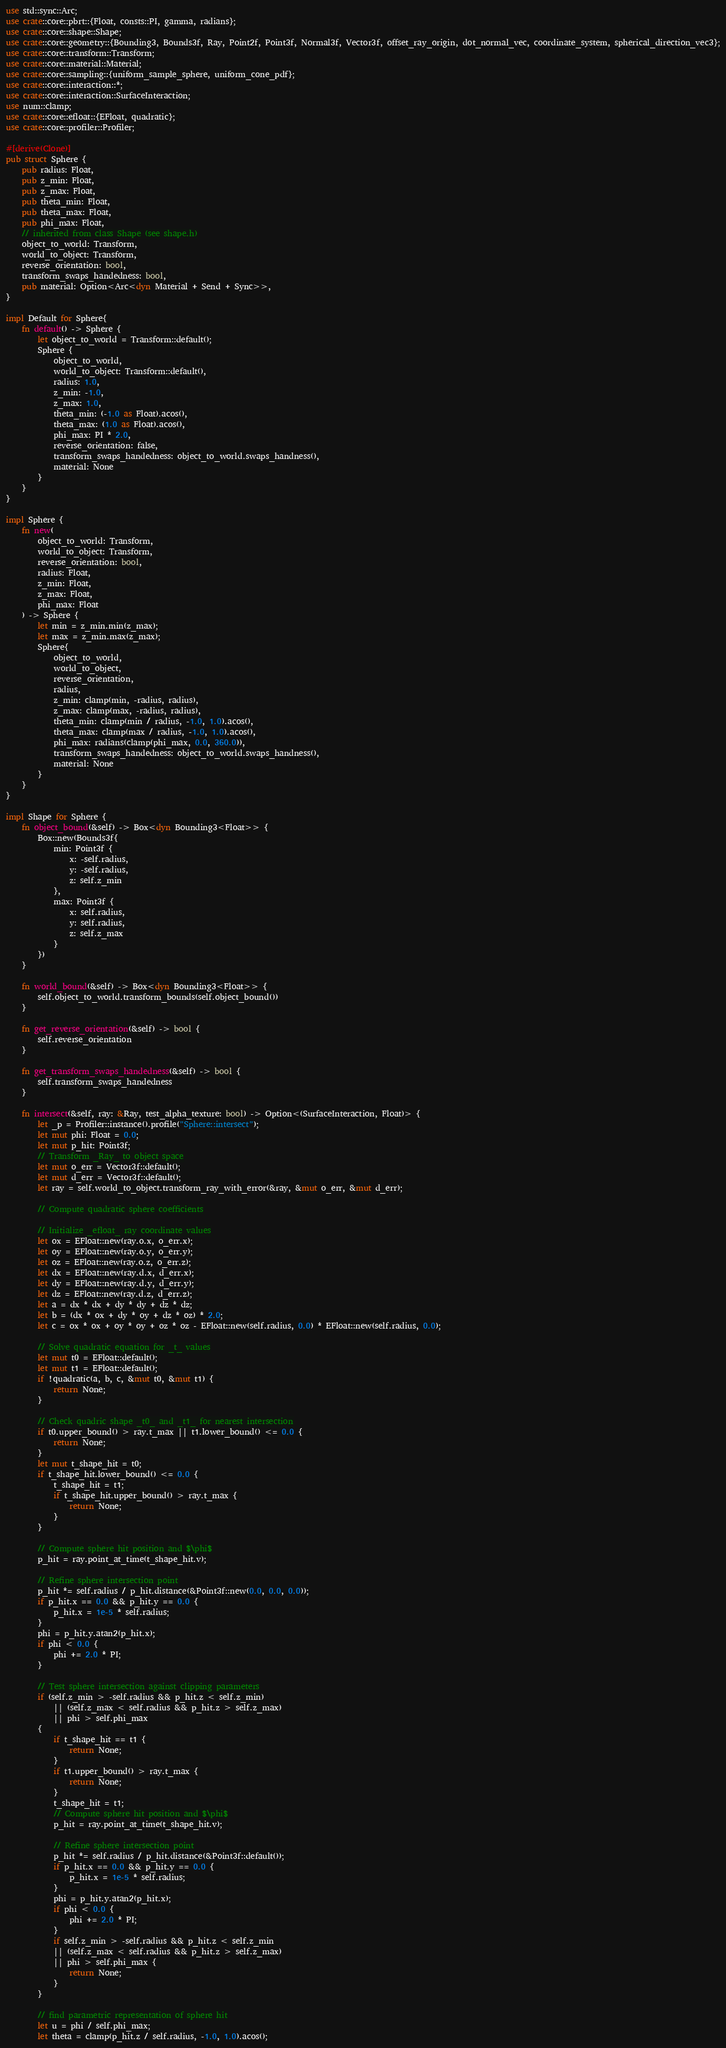<code> <loc_0><loc_0><loc_500><loc_500><_Rust_>use std::sync::Arc;
use crate::core::pbrt::{Float, consts::PI, gamma, radians};
use crate::core::shape::Shape;
use crate::core::geometry::{Bounding3, Bounds3f, Ray, Point2f, Point3f, Normal3f, Vector3f, offset_ray_origin, dot_normal_vec, coordinate_system, spherical_direction_vec3};
use crate::core::transform::Transform;
use crate::core::material::Material;
use crate::core::sampling::{uniform_sample_sphere, uniform_cone_pdf};
use crate::core::interaction::*;
use crate::core::interaction::SurfaceInteraction;
use num::clamp;
use crate::core::efloat::{EFloat, quadratic};
use crate::core::profiler::Profiler;

#[derive(Clone)]
pub struct Sphere {
    pub radius: Float,
    pub z_min: Float,
    pub z_max: Float,
    pub theta_min: Float,
    pub theta_max: Float,
    pub phi_max: Float,
    // inherited from class Shape (see shape.h)
    object_to_world: Transform,
    world_to_object: Transform,
    reverse_orientation: bool,
    transform_swaps_handedness: bool,
    pub material: Option<Arc<dyn Material + Send + Sync>>,
}

impl Default for Sphere{
    fn default() -> Sphere {
        let object_to_world = Transform::default();
        Sphere {
            object_to_world,
            world_to_object: Transform::default(),
            radius: 1.0,
            z_min: -1.0,
            z_max: 1.0,
            theta_min: (-1.0 as Float).acos(),
            theta_max: (1.0 as Float).acos(),
            phi_max: PI * 2.0,
            reverse_orientation: false,
            transform_swaps_handedness: object_to_world.swaps_handness(),
            material: None
        }
    }
}

impl Sphere {
    fn new(
        object_to_world: Transform,
        world_to_object: Transform,
        reverse_orientation: bool,
        radius: Float,
        z_min: Float,
        z_max: Float,
        phi_max: Float
    ) -> Sphere {
        let min = z_min.min(z_max);
        let max = z_min.max(z_max);
        Sphere{
            object_to_world,
            world_to_object,
            reverse_orientation,
            radius,
            z_min: clamp(min, -radius, radius),
            z_max: clamp(max, -radius, radius),
            theta_min: clamp(min / radius, -1.0, 1.0).acos(),
            theta_max: clamp(max / radius, -1.0, 1.0).acos(),
            phi_max: radians(clamp(phi_max, 0.0, 360.0)),
            transform_swaps_handedness: object_to_world.swaps_handness(),
            material: None
        }
    }
}

impl Shape for Sphere {
    fn object_bound(&self) -> Box<dyn Bounding3<Float>> {
        Box::new(Bounds3f{
            min: Point3f {
                x: -self.radius,
                y: -self.radius,
                z: self.z_min
            },
            max: Point3f {
                x: self.radius,
                y: self.radius,
                z: self.z_max
            }
        })
    }

    fn world_bound(&self) -> Box<dyn Bounding3<Float>> {
        self.object_to_world.transform_bounds(self.object_bound())
    }

    fn get_reverse_orientation(&self) -> bool {
        self.reverse_orientation
    }

    fn get_transform_swaps_handedness(&self) -> bool {
        self.transform_swaps_handedness
    }

    fn intersect(&self, ray: &Ray, test_alpha_texture: bool) -> Option<(SurfaceInteraction, Float)> {
        let _p = Profiler::instance().profile("Sphere::intersect");
        let mut phi: Float = 0.0;
        let mut p_hit: Point3f;
        // Transform _Ray_ to object space
        let mut o_err = Vector3f::default();
        let mut d_err = Vector3f::default();
        let ray = self.world_to_object.transform_ray_with_error(&ray, &mut o_err, &mut d_err);

        // Compute quadratic sphere coefficients

        // Initialize _efloat_ ray coordinate values
        let ox = EFloat::new(ray.o.x, o_err.x);
        let oy = EFloat::new(ray.o.y, o_err.y);
        let oz = EFloat::new(ray.o.z, o_err.z);
        let dx = EFloat::new(ray.d.x, d_err.x);
        let dy = EFloat::new(ray.d.y, d_err.y);
        let dz = EFloat::new(ray.d.z, d_err.z);
        let a = dx * dx + dy * dy + dz * dz;
        let b = (dx * ox + dy * oy + dz * oz) * 2.0;
        let c = ox * ox + oy * oy + oz * oz - EFloat::new(self.radius, 0.0) * EFloat::new(self.radius, 0.0);

        // Solve quadratic equation for _t_ values
        let mut t0 = EFloat::default();
        let mut t1 = EFloat::default();
        if !quadratic(a, b, c, &mut t0, &mut t1) {
            return None;
        }

        // Check quadric shape _t0_ and _t1_ for nearest intersection
        if t0.upper_bound() > ray.t_max || t1.lower_bound() <= 0.0 {
            return None;
        }
        let mut t_shape_hit = t0;
        if t_shape_hit.lower_bound() <= 0.0 {
            t_shape_hit = t1;
            if t_shape_hit.upper_bound() > ray.t_max {
                return None;
            }
        }

        // Compute sphere hit position and $\phi$
        p_hit = ray.point_at_time(t_shape_hit.v);

        // Refine sphere intersection point
        p_hit *= self.radius / p_hit.distance(&Point3f::new(0.0, 0.0, 0.0));
        if p_hit.x == 0.0 && p_hit.y == 0.0 {
            p_hit.x = 1e-5 * self.radius;
        }
        phi = p_hit.y.atan2(p_hit.x);
        if phi < 0.0 {
            phi += 2.0 * PI;
        }

        // Test sphere intersection against clipping parameters
        if (self.z_min > -self.radius && p_hit.z < self.z_min)
            || (self.z_max < self.radius && p_hit.z > self.z_max)
            || phi > self.phi_max
        {
            if t_shape_hit == t1 {
                return None;
            }
            if t1.upper_bound() > ray.t_max {
                return None;
            }
            t_shape_hit = t1;
            // Compute sphere hit position and $\phi$
            p_hit = ray.point_at_time(t_shape_hit.v);

            // Refine sphere intersection point
            p_hit *= self.radius / p_hit.distance(&Point3f::default());
            if p_hit.x == 0.0 && p_hit.y == 0.0 {
                p_hit.x = 1e-5 * self.radius;
            }
            phi = p_hit.y.atan2(p_hit.x);
            if phi < 0.0 {
                phi += 2.0 * PI;
            }
            if self.z_min > -self.radius && p_hit.z < self.z_min
            || (self.z_max < self.radius && p_hit.z > self.z_max)
            || phi > self.phi_max {
                return None;
            }
        }

        // find parametric representation of sphere hit
        let u = phi / self.phi_max;
        let theta = clamp(p_hit.z / self.radius, -1.0, 1.0).acos();</code> 